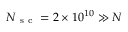<formula> <loc_0><loc_0><loc_500><loc_500>N _ { s c } = 2 \times 1 0 ^ { 1 0 } \gg N</formula> 